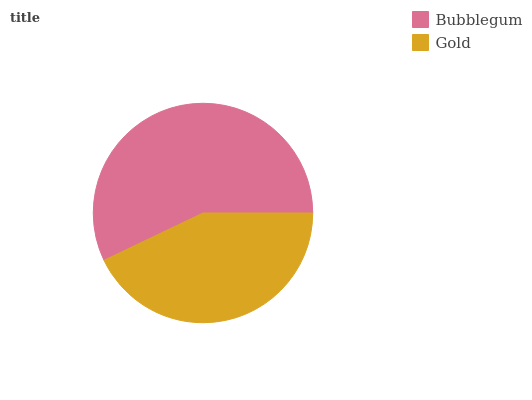Is Gold the minimum?
Answer yes or no. Yes. Is Bubblegum the maximum?
Answer yes or no. Yes. Is Gold the maximum?
Answer yes or no. No. Is Bubblegum greater than Gold?
Answer yes or no. Yes. Is Gold less than Bubblegum?
Answer yes or no. Yes. Is Gold greater than Bubblegum?
Answer yes or no. No. Is Bubblegum less than Gold?
Answer yes or no. No. Is Bubblegum the high median?
Answer yes or no. Yes. Is Gold the low median?
Answer yes or no. Yes. Is Gold the high median?
Answer yes or no. No. Is Bubblegum the low median?
Answer yes or no. No. 